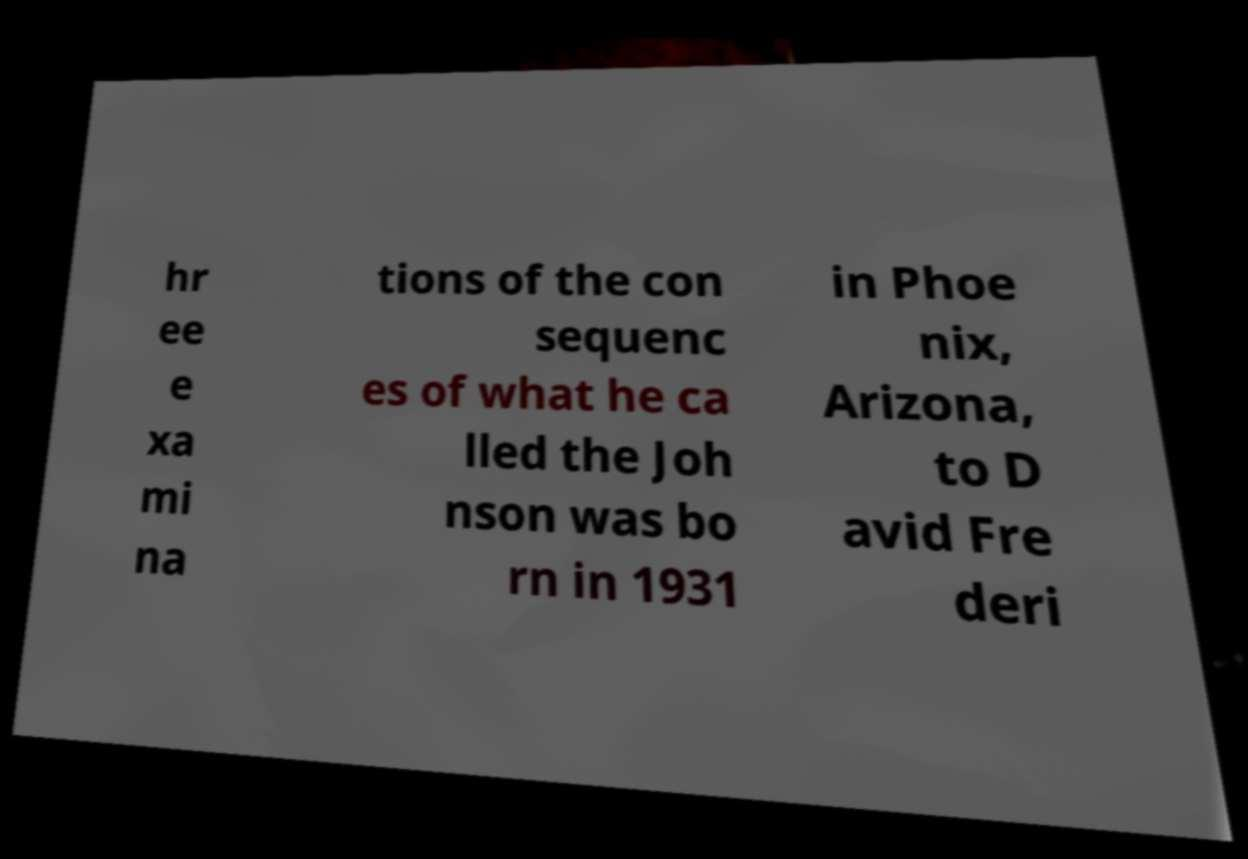Could you assist in decoding the text presented in this image and type it out clearly? hr ee e xa mi na tions of the con sequenc es of what he ca lled the Joh nson was bo rn in 1931 in Phoe nix, Arizona, to D avid Fre deri 